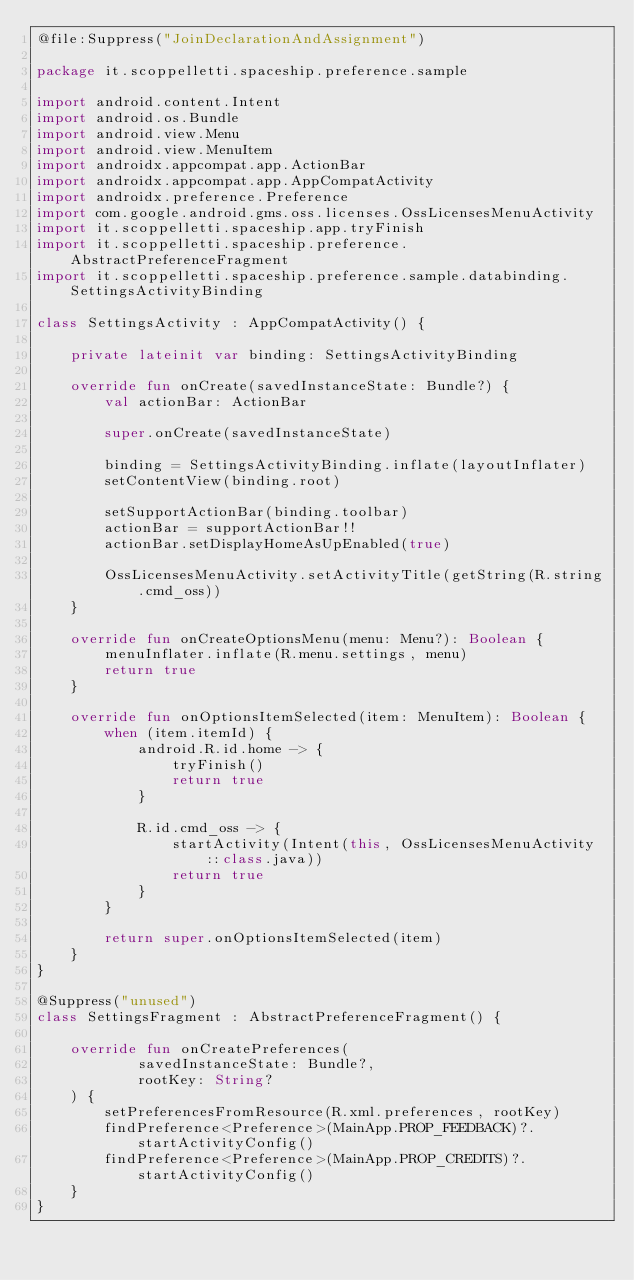Convert code to text. <code><loc_0><loc_0><loc_500><loc_500><_Kotlin_>@file:Suppress("JoinDeclarationAndAssignment")

package it.scoppelletti.spaceship.preference.sample

import android.content.Intent
import android.os.Bundle
import android.view.Menu
import android.view.MenuItem
import androidx.appcompat.app.ActionBar
import androidx.appcompat.app.AppCompatActivity
import androidx.preference.Preference
import com.google.android.gms.oss.licenses.OssLicensesMenuActivity
import it.scoppelletti.spaceship.app.tryFinish
import it.scoppelletti.spaceship.preference.AbstractPreferenceFragment
import it.scoppelletti.spaceship.preference.sample.databinding.SettingsActivityBinding

class SettingsActivity : AppCompatActivity() {

    private lateinit var binding: SettingsActivityBinding

    override fun onCreate(savedInstanceState: Bundle?) {
        val actionBar: ActionBar

        super.onCreate(savedInstanceState)

        binding = SettingsActivityBinding.inflate(layoutInflater)
        setContentView(binding.root)

        setSupportActionBar(binding.toolbar)
        actionBar = supportActionBar!!
        actionBar.setDisplayHomeAsUpEnabled(true)

        OssLicensesMenuActivity.setActivityTitle(getString(R.string.cmd_oss))
    }

    override fun onCreateOptionsMenu(menu: Menu?): Boolean {
        menuInflater.inflate(R.menu.settings, menu)
        return true
    }

    override fun onOptionsItemSelected(item: MenuItem): Boolean {
        when (item.itemId) {
            android.R.id.home -> {
                tryFinish()
                return true
            }

            R.id.cmd_oss -> {
                startActivity(Intent(this, OssLicensesMenuActivity::class.java))
                return true
            }
        }

        return super.onOptionsItemSelected(item)
    }
}

@Suppress("unused")
class SettingsFragment : AbstractPreferenceFragment() {

    override fun onCreatePreferences(
            savedInstanceState: Bundle?,
            rootKey: String?
    ) {
        setPreferencesFromResource(R.xml.preferences, rootKey)
        findPreference<Preference>(MainApp.PROP_FEEDBACK)?.startActivityConfig()
        findPreference<Preference>(MainApp.PROP_CREDITS)?.startActivityConfig()
    }
}

</code> 